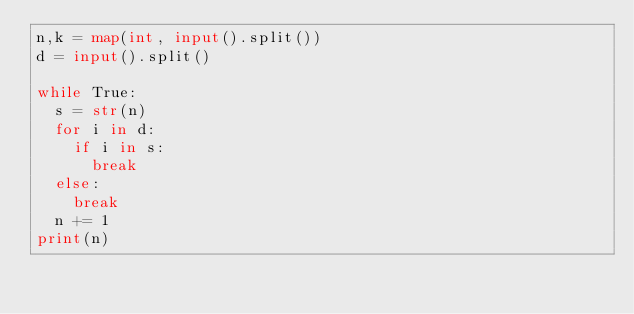Convert code to text. <code><loc_0><loc_0><loc_500><loc_500><_Python_>n,k = map(int, input().split())
d = input().split()

while True:
  s = str(n)
  for i in d:
    if i in s:
      break
  else:
    break
  n += 1
print(n)

</code> 